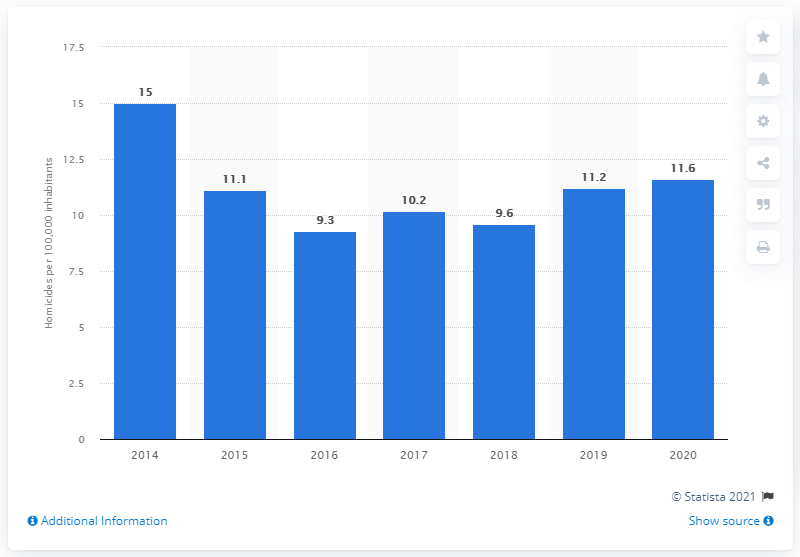Specify some key components in this picture. In 2020, the murder rate in Panama was 11.6 per 100,000 inhabitants. 